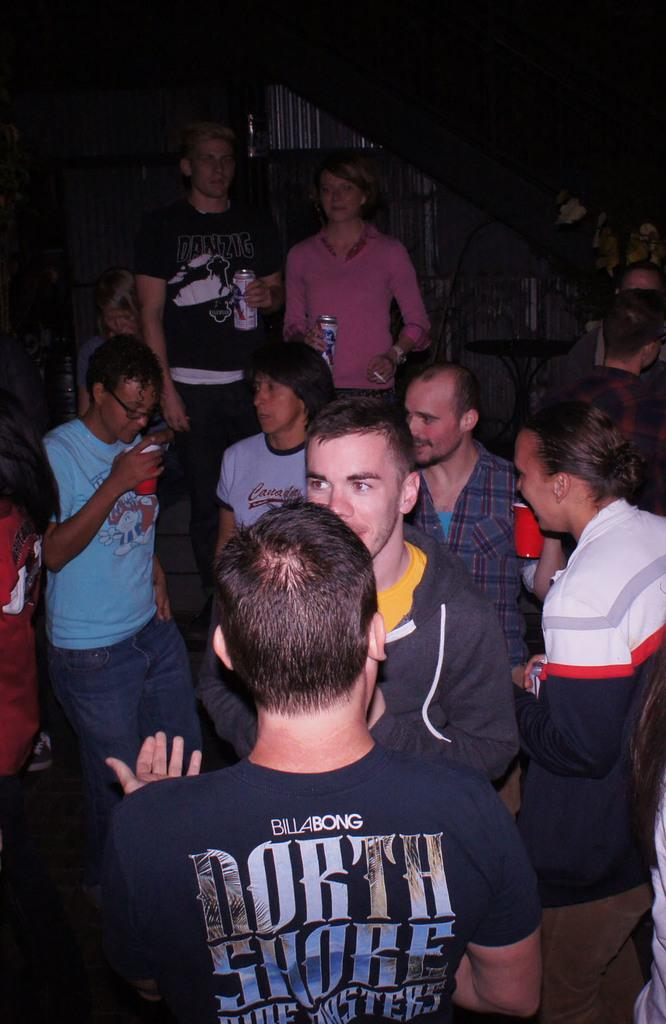What is the main subject of the image? The main subject of the image is a group of people. What are some of the people in the image holding? Some people in the image are holding bottles in their hands. How many ants are crawling on the people in the image? There are no ants present in the image; it features a group of people holding bottles. 